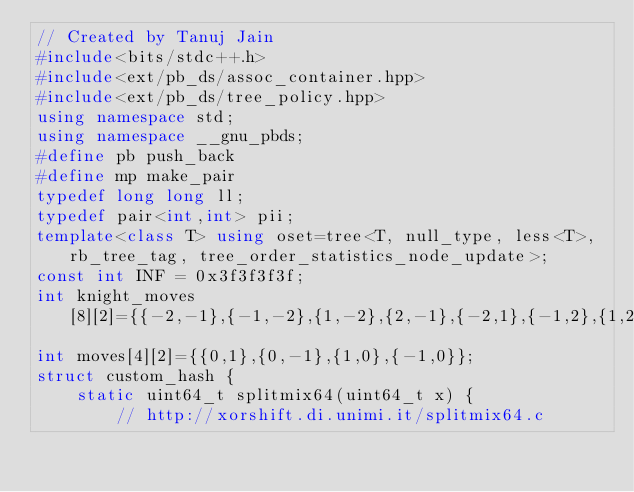<code> <loc_0><loc_0><loc_500><loc_500><_C++_>// Created by Tanuj Jain
#include<bits/stdc++.h>
#include<ext/pb_ds/assoc_container.hpp>
#include<ext/pb_ds/tree_policy.hpp>
using namespace std;
using namespace __gnu_pbds;
#define pb push_back
#define mp make_pair
typedef long long ll;
typedef pair<int,int> pii;
template<class T> using oset=tree<T, null_type, less<T>, rb_tree_tag, tree_order_statistics_node_update>;
const int INF = 0x3f3f3f3f;
int knight_moves[8][2]={{-2,-1},{-1,-2},{1,-2},{2,-1},{-2,1},{-1,2},{1,2},{2,1}};
int moves[4][2]={{0,1},{0,-1},{1,0},{-1,0}};
struct custom_hash {
    static uint64_t splitmix64(uint64_t x) {
        // http://xorshift.di.unimi.it/splitmix64.c</code> 